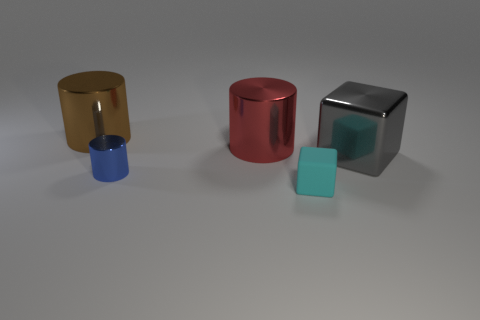Subtract all small blue metal cylinders. How many cylinders are left? 2 Add 4 blue objects. How many objects exist? 9 Subtract all cylinders. How many objects are left? 2 Subtract all tiny blue cylinders. Subtract all yellow matte spheres. How many objects are left? 4 Add 2 large gray metallic objects. How many large gray metallic objects are left? 3 Add 1 tiny cyan cubes. How many tiny cyan cubes exist? 2 Subtract 0 green blocks. How many objects are left? 5 Subtract all red cylinders. Subtract all gray spheres. How many cylinders are left? 2 